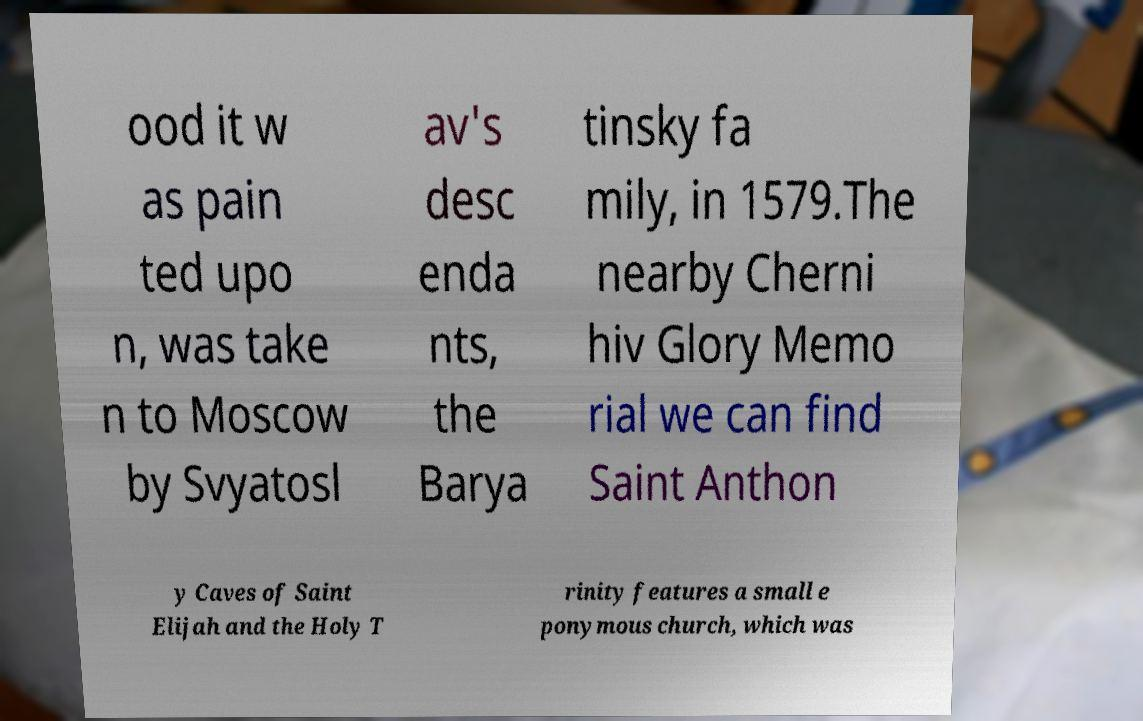Could you assist in decoding the text presented in this image and type it out clearly? ood it w as pain ted upo n, was take n to Moscow by Svyatosl av's desc enda nts, the Barya tinsky fa mily, in 1579.The nearby Cherni hiv Glory Memo rial we can find Saint Anthon y Caves of Saint Elijah and the Holy T rinity features a small e ponymous church, which was 